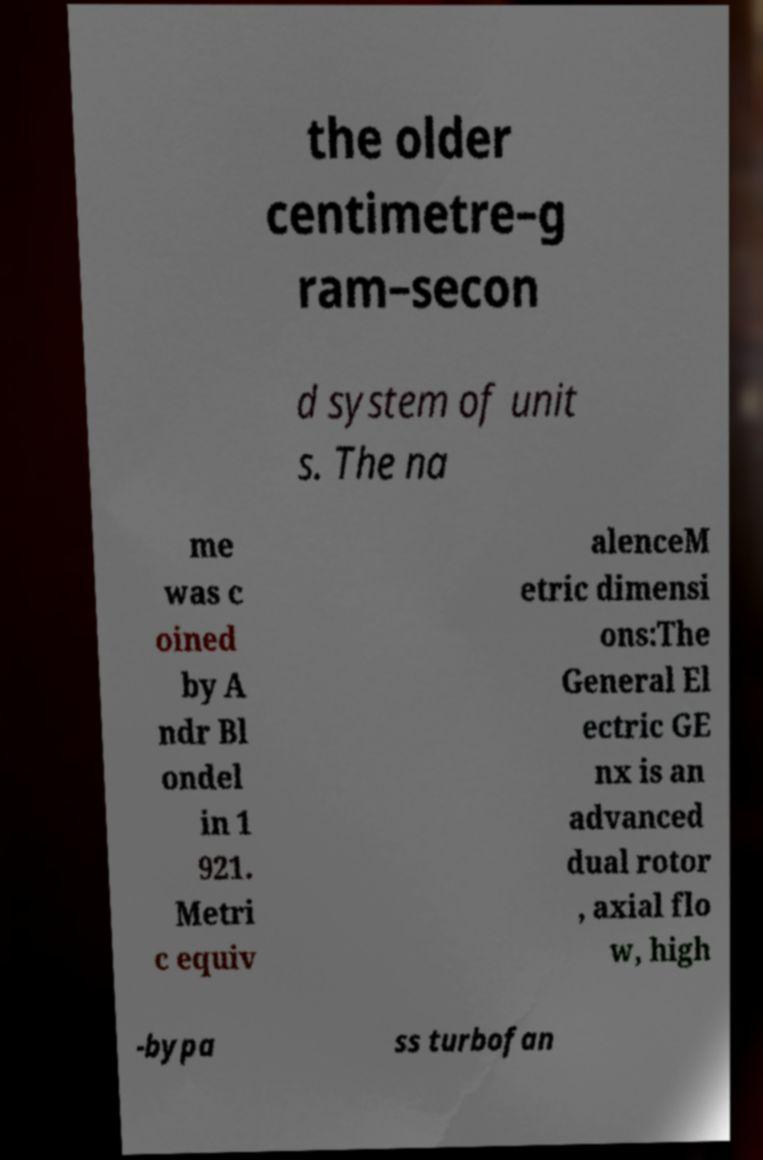Can you accurately transcribe the text from the provided image for me? the older centimetre–g ram–secon d system of unit s. The na me was c oined by A ndr Bl ondel in 1 921. Metri c equiv alenceM etric dimensi ons:The General El ectric GE nx is an advanced dual rotor , axial flo w, high -bypa ss turbofan 